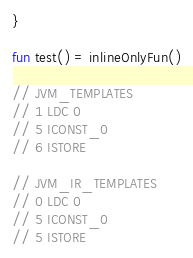Convert code to text. <code><loc_0><loc_0><loc_500><loc_500><_Kotlin_>}

fun test() = inlineOnlyFun()

// JVM_TEMPLATES
// 1 LDC 0
// 5 ICONST_0
// 6 ISTORE

// JVM_IR_TEMPLATES
// 0 LDC 0
// 5 ICONST_0
// 5 ISTORE</code> 